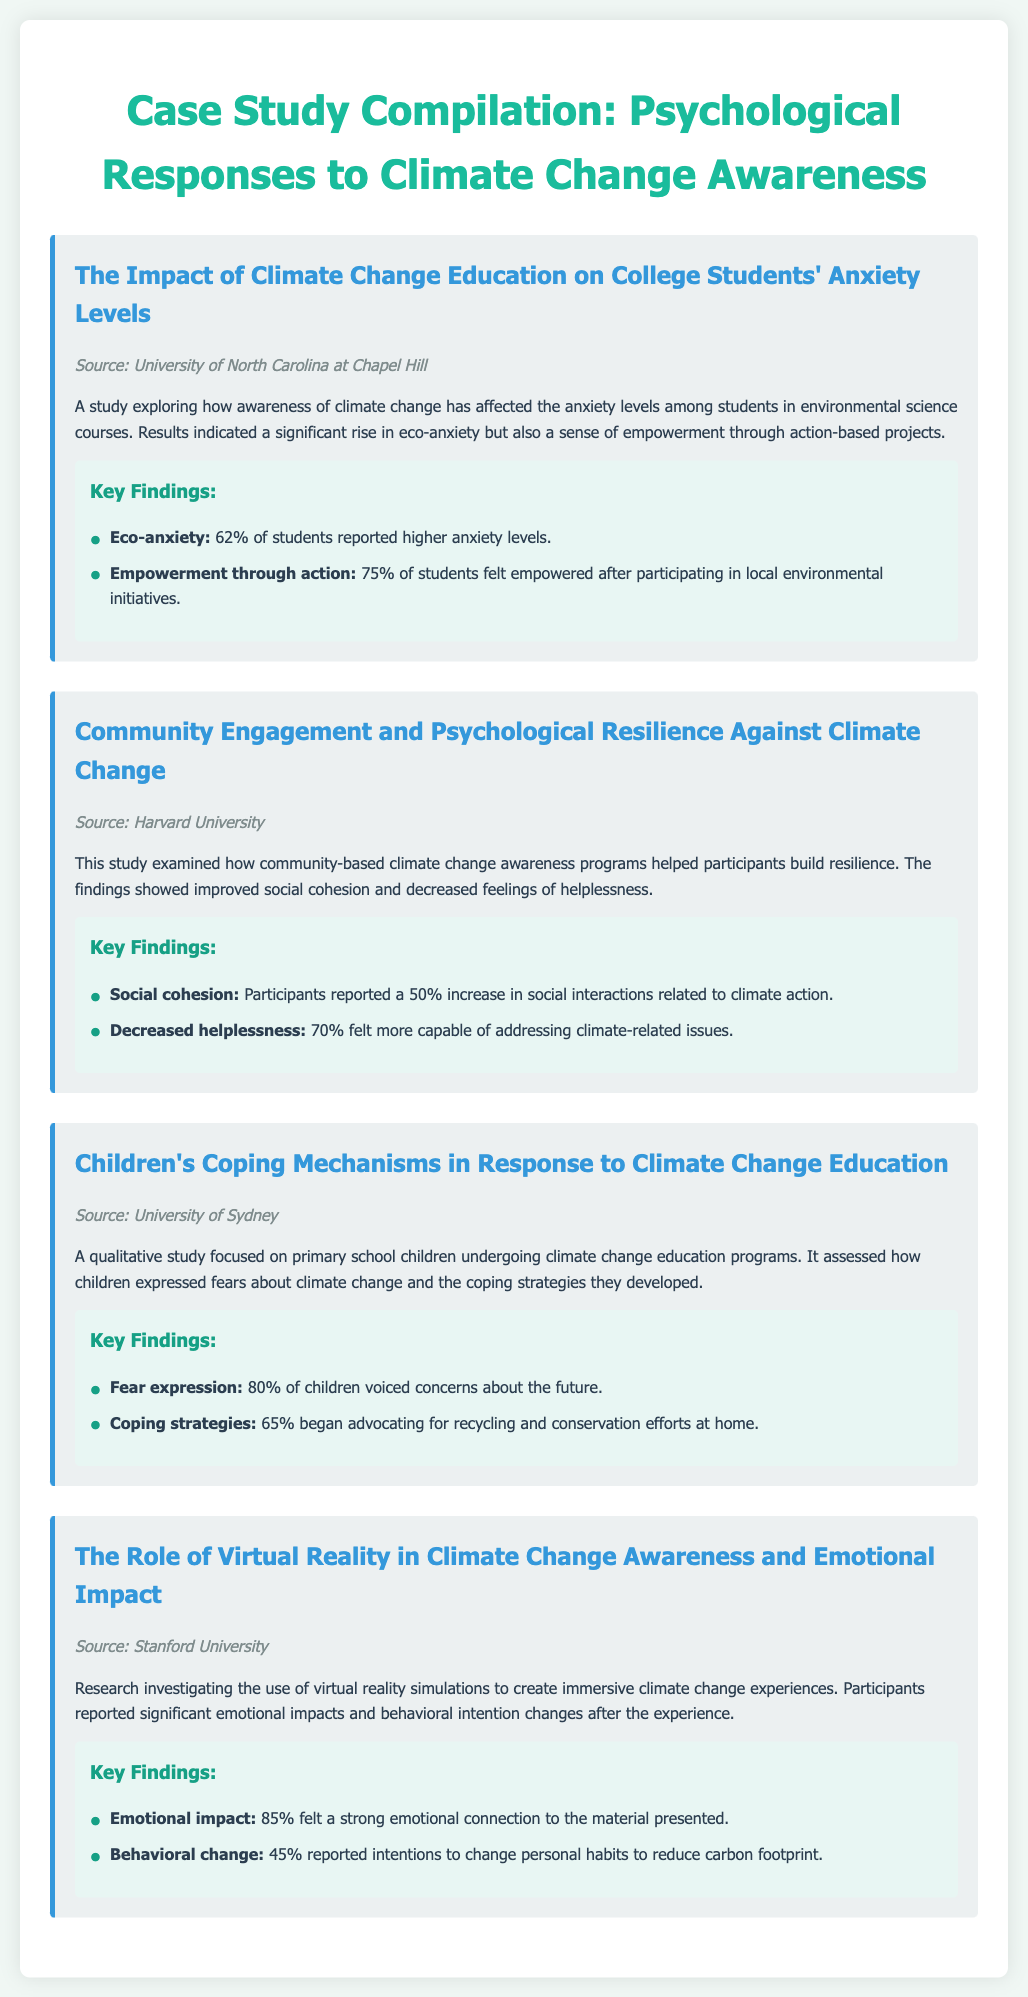What is the source of the study on eco-anxiety? The source is mentioned in the case study titled "The Impact of Climate Change Education on College Students' Anxiety Levels."
Answer: University of North Carolina at Chapel Hill What percentage of children voiced concerns about the future? This information is found in the findings of the study focused on children's coping mechanisms.
Answer: 80% What is the emotional impact percentage reported by participants using virtual reality? This statistic is included in the key findings of the study regarding virtual reality's emotional impact.
Answer: 85% How many students felt empowered after participating in local environmental initiatives? This detail is found under the key findings of the eco-anxiety study.
Answer: 75% What was the increase in social interactions related to climate action among participants? The increase in social interactions is noted in the findings of the community engagement study.
Answer: 50% What coping strategy was mentioned by a portion of children in the education program? The coping strategy is described in the findings of the study about children’s coping mechanisms.
Answer: Advocating for recycling and conservation efforts at home What percentage of participants reported intentions to change personal habits after the virtual reality experience? This statistic is included in the findings from the study on virtual reality.
Answer: 45% 